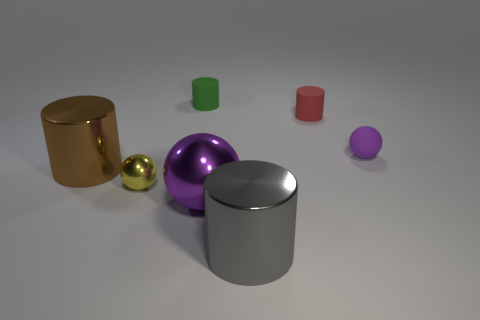Add 1 purple objects. How many objects exist? 8 Subtract all spheres. How many objects are left? 4 Subtract all matte objects. Subtract all gray metallic objects. How many objects are left? 3 Add 7 matte balls. How many matte balls are left? 8 Add 5 rubber cylinders. How many rubber cylinders exist? 7 Subtract 0 red spheres. How many objects are left? 7 